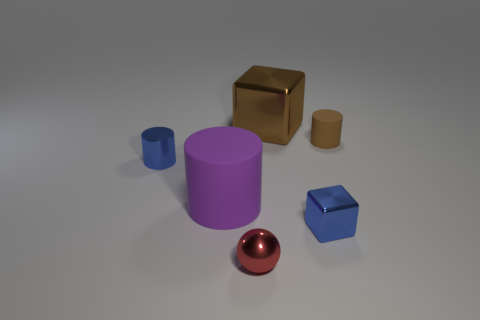Subtract all blue spheres. Subtract all brown blocks. How many spheres are left? 1 Add 3 blue shiny cubes. How many objects exist? 9 Subtract all balls. How many objects are left? 5 Add 1 small red shiny balls. How many small red shiny balls are left? 2 Add 5 brown blocks. How many brown blocks exist? 6 Subtract 0 blue spheres. How many objects are left? 6 Subtract all blue cylinders. Subtract all big brown blocks. How many objects are left? 4 